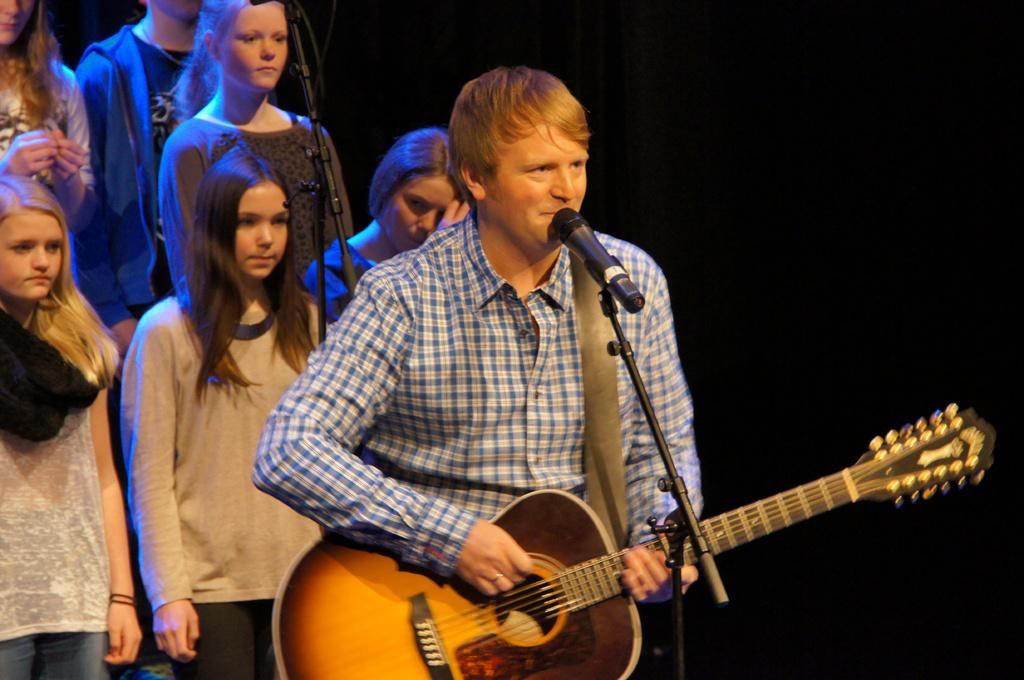What is the man in the image doing? The man is in front of a mic and holding a guitar. What can be inferred about the man's activity in the image? The man is likely performing or singing, given his position in front of a mic and holding a guitar. Can you describe the background of the image? There are girls in the background of the image. What type of beef is being cooked in the image? There is no beef present in the image; it features a man with a guitar in front of a mic. Can you describe the faucet in the image? There is no faucet present in the image. 